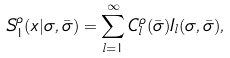Convert formula to latex. <formula><loc_0><loc_0><loc_500><loc_500>S ^ { \rho } _ { 1 } ( x | \sigma , \bar { \sigma } ) = \sum _ { l = 1 } ^ { \infty } C ^ { \rho } _ { l } ( \bar { \sigma } ) I _ { l } ( \sigma , \bar { \sigma } ) ,</formula> 